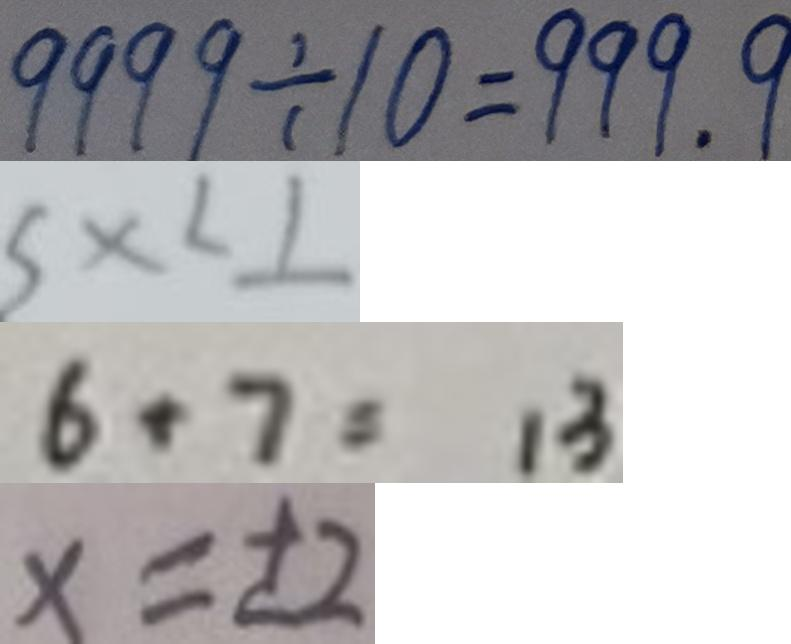Convert formula to latex. <formula><loc_0><loc_0><loc_500><loc_500>9 9 9 9 \div 1 0 = 9 9 9 . 9 
 5 x < 1 
 6 + 7 = 1 3 
 x = \pm 2</formula> 